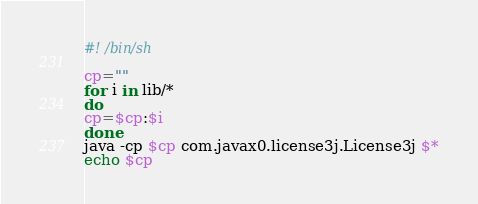<code> <loc_0><loc_0><loc_500><loc_500><_Bash_>#! /bin/sh

cp=""
for i in lib/* 
do
cp=$cp:$i
done
java -cp $cp com.javax0.license3j.License3j $*
echo $cp</code> 